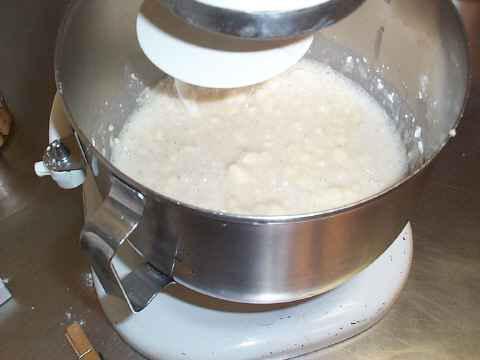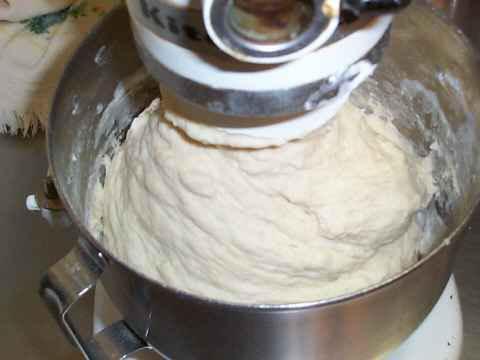The first image is the image on the left, the second image is the image on the right. Analyze the images presented: Is the assertion "The images show two different stages of dough in a mixer." valid? Answer yes or no. Yes. 